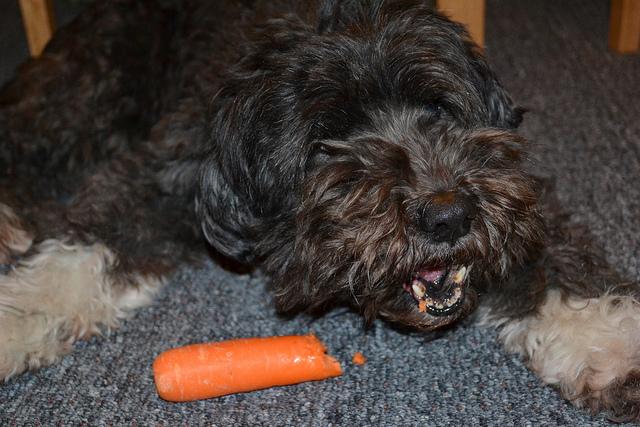Is the dog on the leash?
Short answer required. No. What type of carpet is that?
Answer briefly. Shag. Is this normal food for dogs?
Quick response, please. No. Does the dog look happy?
Give a very brief answer. No. How many dogs are there?
Keep it brief. 1. 